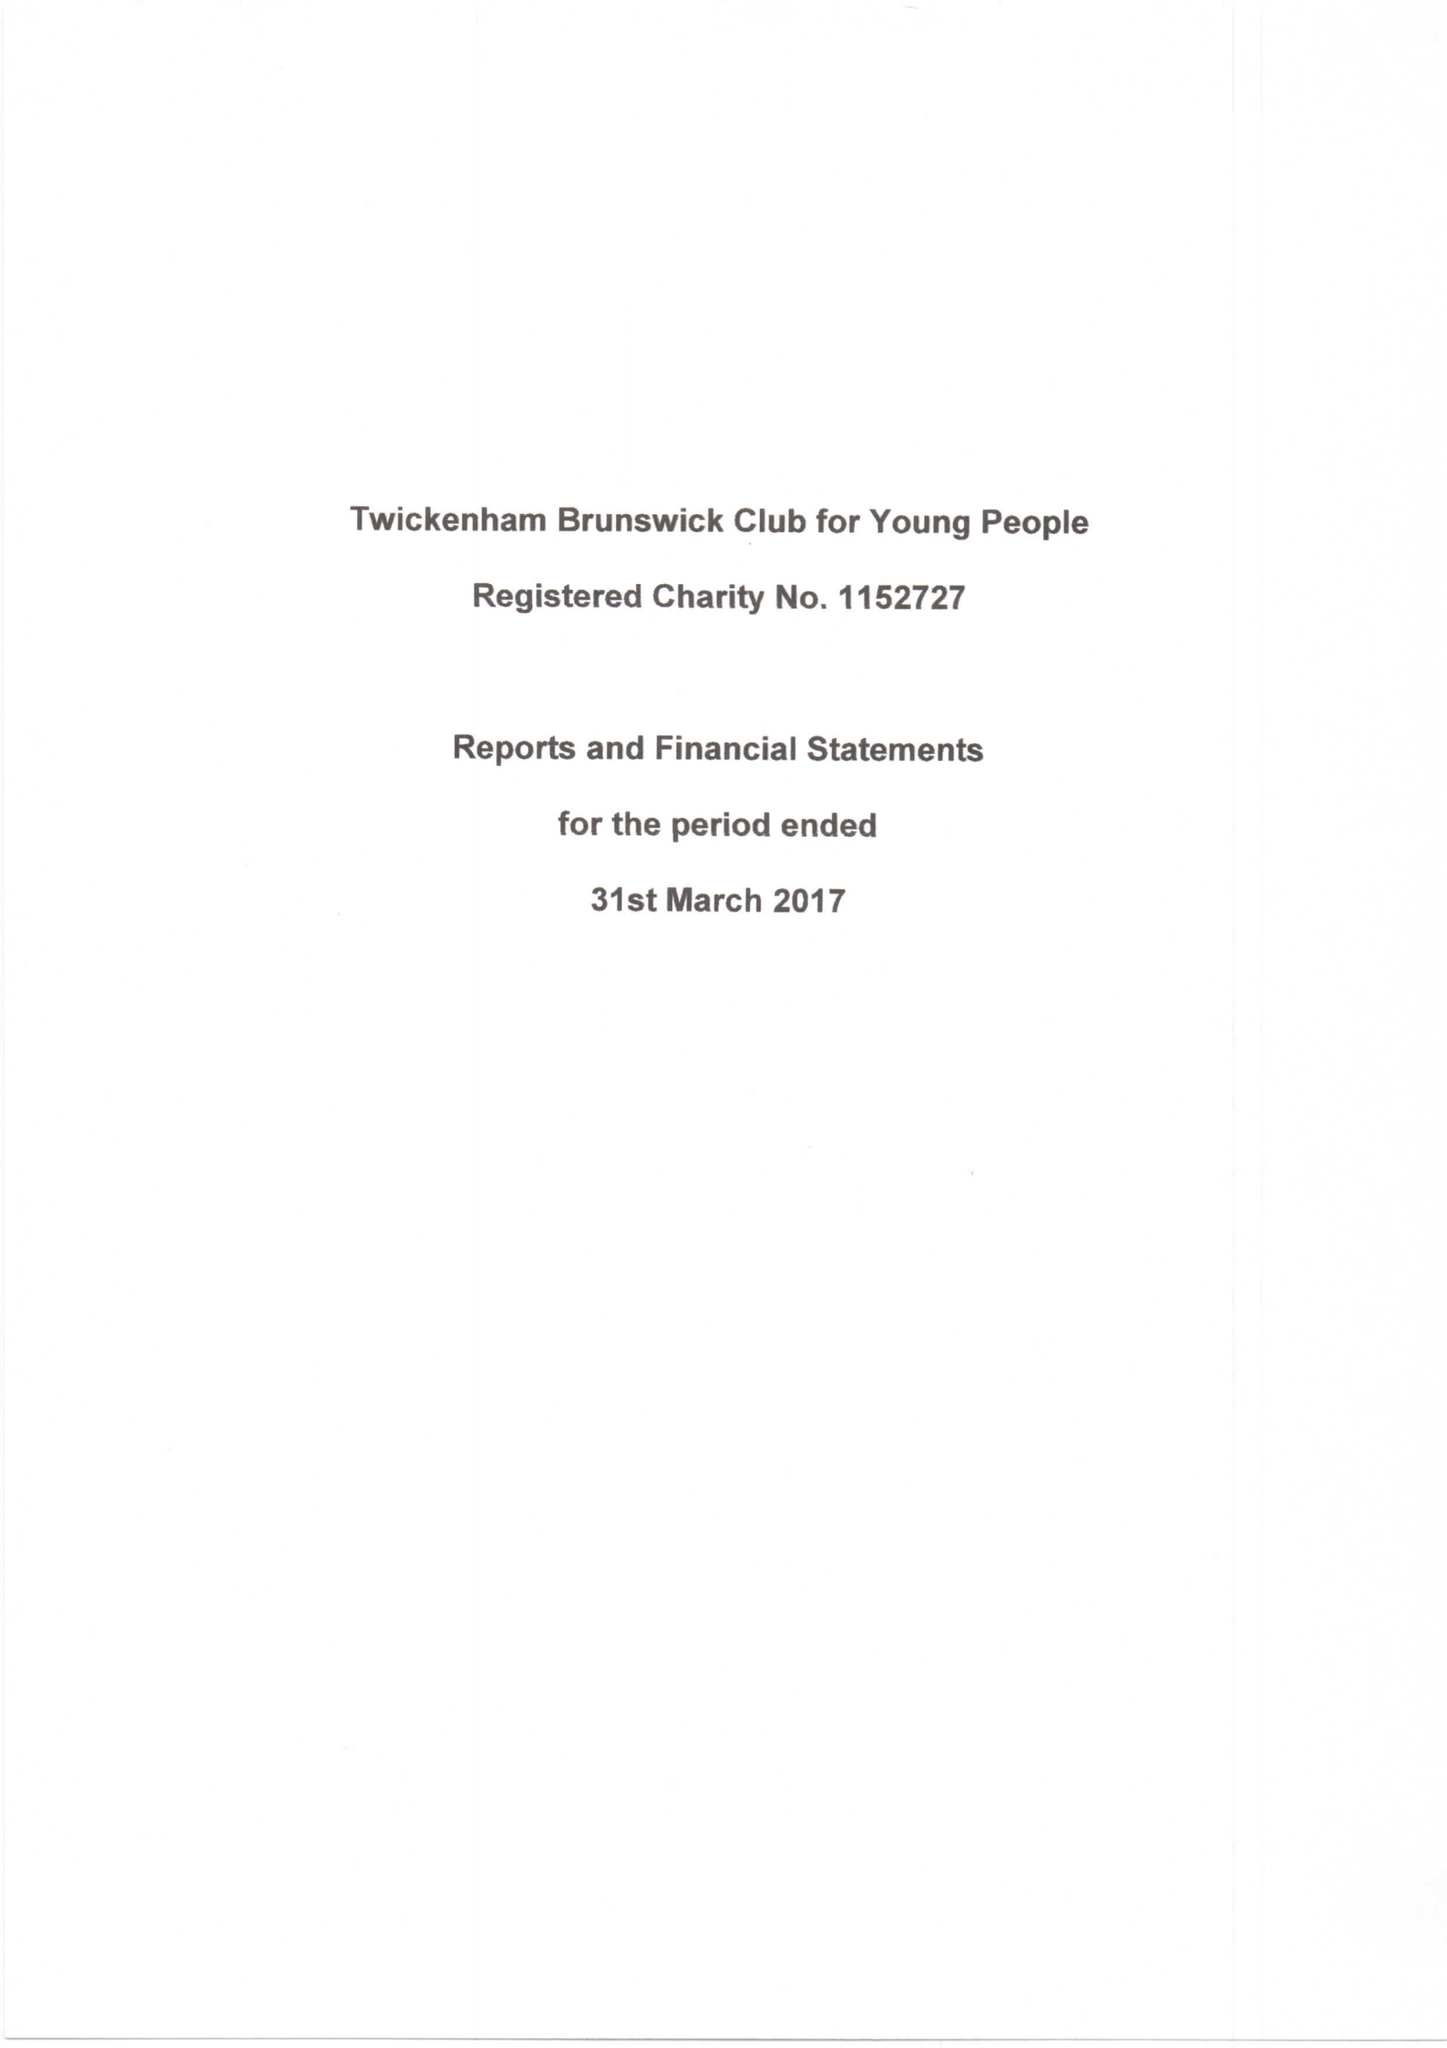What is the value for the charity_name?
Answer the question using a single word or phrase. Twickenham Brunswick Club For Young People 